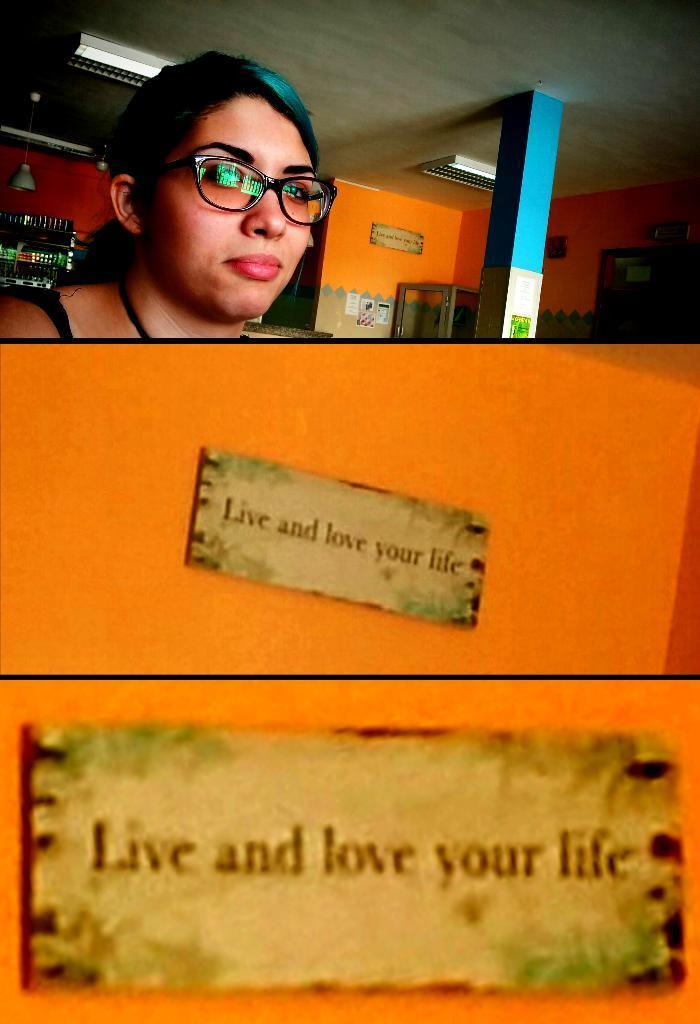Please provide a concise description of this image. In this image there is a wall. There are two boards on the wall. There is a person behind the wall. There is another in the background. There is roof with lights. 